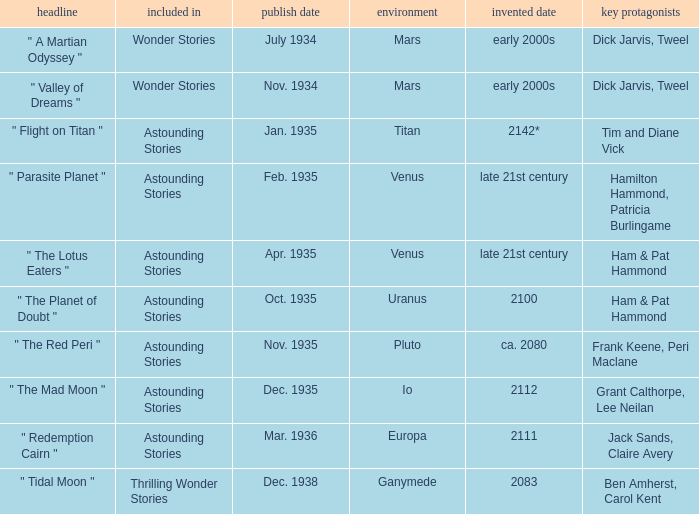What is the release date of the publication set in the year 2112? Dec. 1935. 